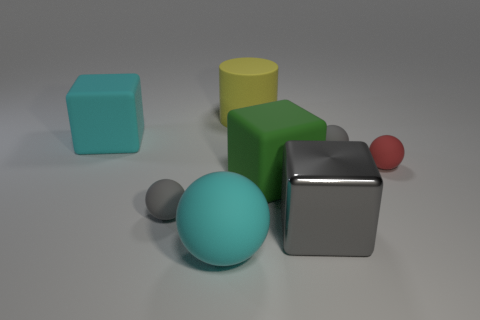Add 1 small brown rubber balls. How many objects exist? 9 Subtract all tiny rubber spheres. How many spheres are left? 1 Subtract 1 cubes. How many cubes are left? 2 Subtract all cyan blocks. How many gray balls are left? 2 Subtract all cylinders. How many objects are left? 7 Subtract all gray spheres. How many spheres are left? 2 Subtract all brown cylinders. Subtract all gray spheres. How many cylinders are left? 1 Subtract all gray balls. Subtract all small matte objects. How many objects are left? 3 Add 6 shiny things. How many shiny things are left? 7 Add 7 yellow matte things. How many yellow matte things exist? 8 